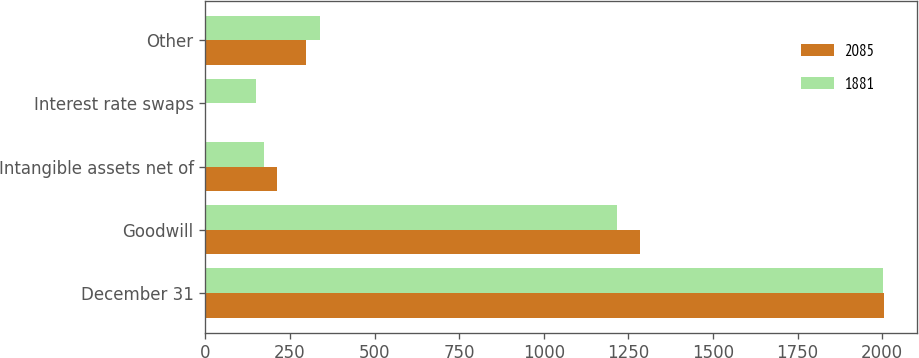Convert chart. <chart><loc_0><loc_0><loc_500><loc_500><stacked_bar_chart><ecel><fcel>December 31<fcel>Goodwill<fcel>Intangible assets net of<fcel>Interest rate swaps<fcel>Other<nl><fcel>2085<fcel>2004<fcel>1283<fcel>212<fcel>3<fcel>296<nl><fcel>1881<fcel>2003<fcel>1215<fcel>173<fcel>150<fcel>338<nl></chart> 